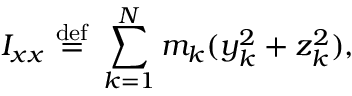Convert formula to latex. <formula><loc_0><loc_0><loc_500><loc_500>I _ { x x } \ { \stackrel { d e f } { = } } \ \sum _ { k = 1 } ^ { N } m _ { k } ( y _ { k } ^ { 2 } + z _ { k } ^ { 2 } ) , \,</formula> 